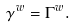Convert formula to latex. <formula><loc_0><loc_0><loc_500><loc_500>\gamma ^ { w } = \Gamma ^ { w } .</formula> 